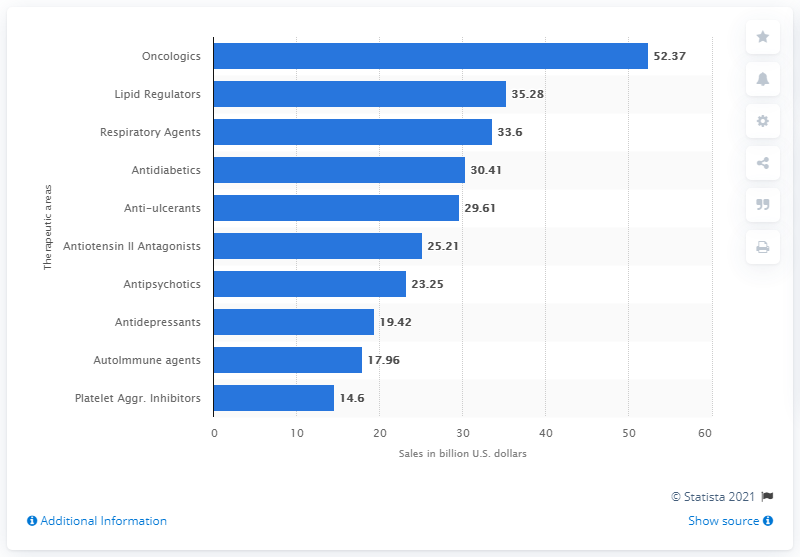List a handful of essential elements in this visual. What is the distinction between oncologic and lipid regulators? The question of how to use them in the prevention and treatment of cancers and lipid metabolism disorders is a subject of debate. In 2009, the sales of antidepressants in the United States totaled 19.42 billion dollars. Oncologics is the number one therapeutic area in terms of providing effective treatments for cancer. 